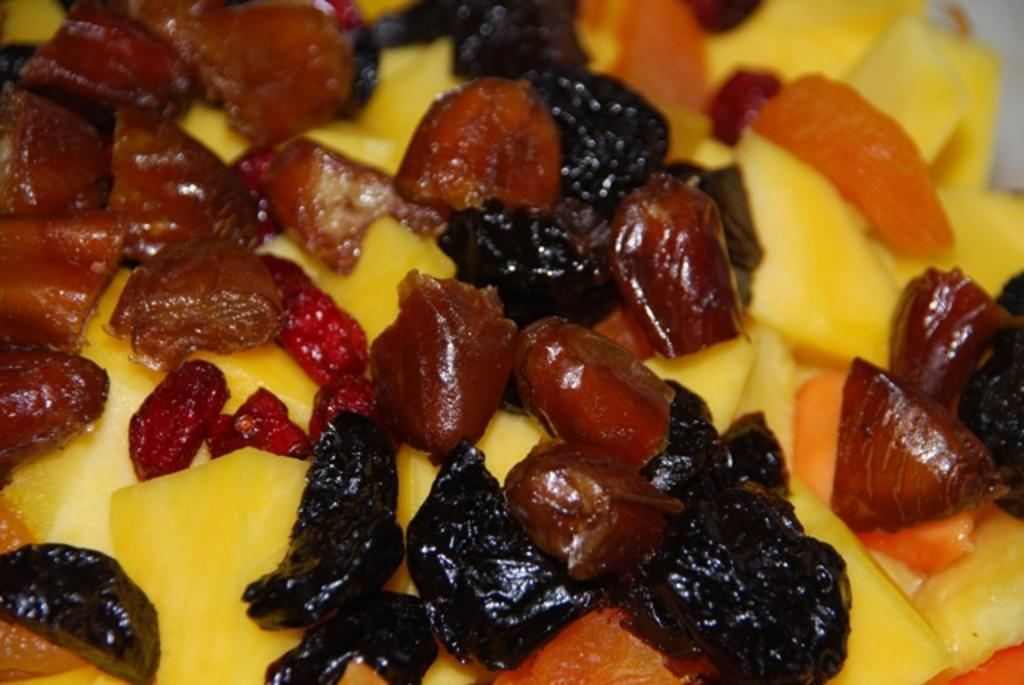What type of food can be seen in the image? There are some fruits in the image. What type of glass is being used to hold the fruits in the image? There is no glass present in the image; the fruits are not contained in any glass object. 